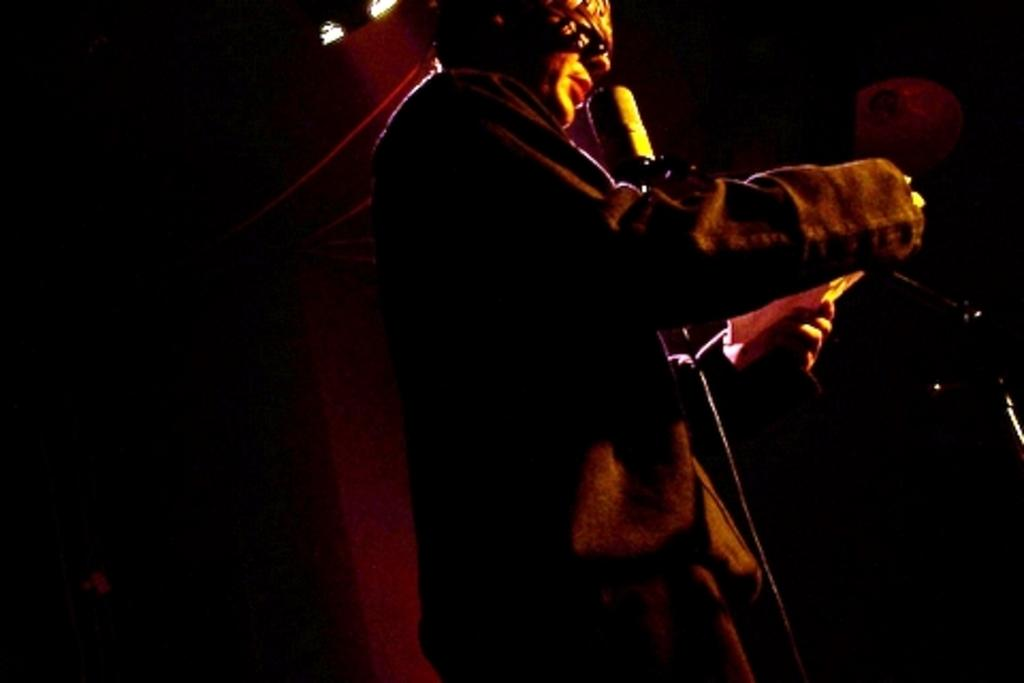How would you describe the lighting in the image? The image is dark. Can you identify any people in the image? Yes, there is a person standing in the image. How does the person in the image turn the spoon around? There is no spoon present in the image, so the person cannot turn it around. 